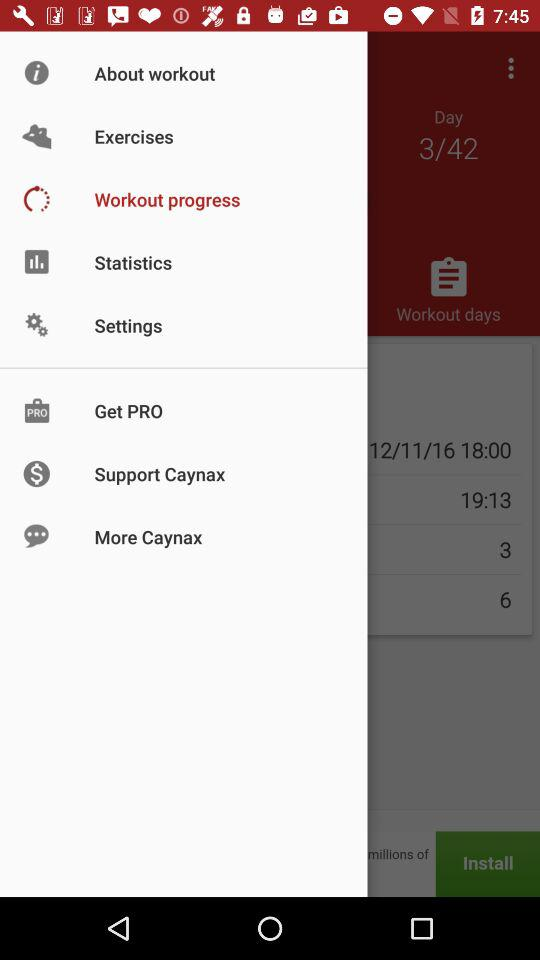How many more items are there in the first row than in the second row?
Answer the question using a single word or phrase. 2 